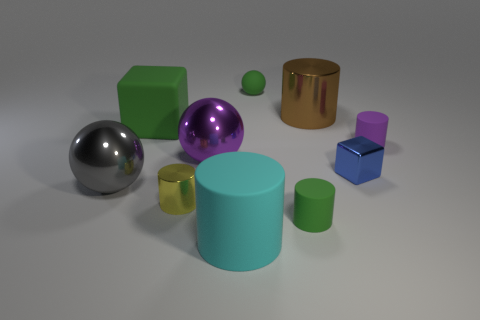Subtract all cyan cylinders. How many cylinders are left? 4 Subtract all big metal cylinders. How many cylinders are left? 4 Subtract all red cylinders. Subtract all cyan balls. How many cylinders are left? 5 Subtract all cubes. How many objects are left? 8 Subtract 0 gray blocks. How many objects are left? 10 Subtract all blue metal blocks. Subtract all large gray spheres. How many objects are left? 8 Add 5 cyan rubber cylinders. How many cyan rubber cylinders are left? 6 Add 2 purple metallic things. How many purple metallic things exist? 3 